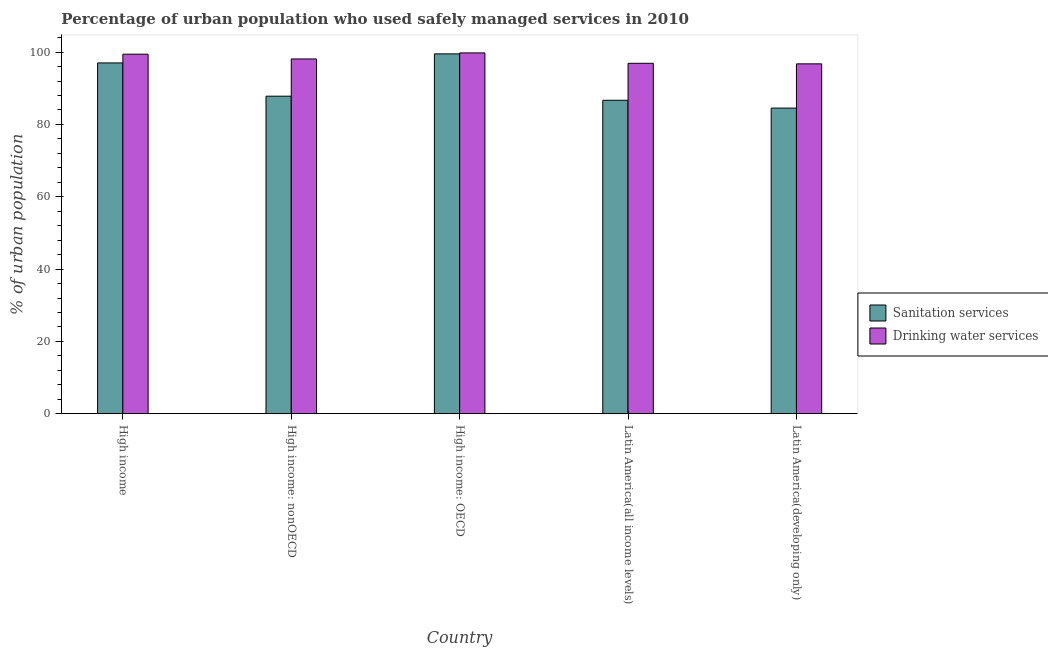How many groups of bars are there?
Give a very brief answer. 5. Are the number of bars on each tick of the X-axis equal?
Your answer should be compact. Yes. How many bars are there on the 5th tick from the left?
Offer a terse response. 2. What is the label of the 1st group of bars from the left?
Provide a short and direct response. High income. In how many cases, is the number of bars for a given country not equal to the number of legend labels?
Your answer should be very brief. 0. What is the percentage of urban population who used drinking water services in Latin America(all income levels)?
Provide a short and direct response. 96.9. Across all countries, what is the maximum percentage of urban population who used sanitation services?
Your response must be concise. 99.5. Across all countries, what is the minimum percentage of urban population who used drinking water services?
Offer a very short reply. 96.74. In which country was the percentage of urban population who used drinking water services maximum?
Keep it short and to the point. High income: OECD. In which country was the percentage of urban population who used drinking water services minimum?
Give a very brief answer. Latin America(developing only). What is the total percentage of urban population who used sanitation services in the graph?
Offer a terse response. 455.48. What is the difference between the percentage of urban population who used sanitation services in Latin America(all income levels) and that in Latin America(developing only)?
Make the answer very short. 2.16. What is the difference between the percentage of urban population who used drinking water services in Latin America(developing only) and the percentage of urban population who used sanitation services in High income: nonOECD?
Give a very brief answer. 8.94. What is the average percentage of urban population who used drinking water services per country?
Your answer should be compact. 98.18. What is the difference between the percentage of urban population who used drinking water services and percentage of urban population who used sanitation services in Latin America(all income levels)?
Ensure brevity in your answer.  10.23. In how many countries, is the percentage of urban population who used drinking water services greater than 44 %?
Ensure brevity in your answer.  5. What is the ratio of the percentage of urban population who used drinking water services in High income: nonOECD to that in Latin America(all income levels)?
Give a very brief answer. 1.01. What is the difference between the highest and the second highest percentage of urban population who used drinking water services?
Offer a terse response. 0.35. What is the difference between the highest and the lowest percentage of urban population who used drinking water services?
Ensure brevity in your answer.  3.03. In how many countries, is the percentage of urban population who used drinking water services greater than the average percentage of urban population who used drinking water services taken over all countries?
Your response must be concise. 2. Is the sum of the percentage of urban population who used drinking water services in High income: nonOECD and Latin America(all income levels) greater than the maximum percentage of urban population who used sanitation services across all countries?
Keep it short and to the point. Yes. What does the 1st bar from the left in High income represents?
Make the answer very short. Sanitation services. What does the 2nd bar from the right in Latin America(developing only) represents?
Make the answer very short. Sanitation services. How many bars are there?
Give a very brief answer. 10. Are all the bars in the graph horizontal?
Offer a terse response. No. How many countries are there in the graph?
Provide a short and direct response. 5. Does the graph contain any zero values?
Keep it short and to the point. No. What is the title of the graph?
Your answer should be very brief. Percentage of urban population who used safely managed services in 2010. Does "Register a business" appear as one of the legend labels in the graph?
Offer a very short reply. No. What is the label or title of the X-axis?
Ensure brevity in your answer.  Country. What is the label or title of the Y-axis?
Offer a terse response. % of urban population. What is the % of urban population in Sanitation services in High income?
Provide a short and direct response. 96.99. What is the % of urban population in Drinking water services in High income?
Give a very brief answer. 99.41. What is the % of urban population of Sanitation services in High income: nonOECD?
Offer a terse response. 87.8. What is the % of urban population of Drinking water services in High income: nonOECD?
Provide a short and direct response. 98.1. What is the % of urban population of Sanitation services in High income: OECD?
Your answer should be very brief. 99.5. What is the % of urban population in Drinking water services in High income: OECD?
Your response must be concise. 99.77. What is the % of urban population in Sanitation services in Latin America(all income levels)?
Your response must be concise. 86.67. What is the % of urban population in Drinking water services in Latin America(all income levels)?
Provide a succinct answer. 96.9. What is the % of urban population of Sanitation services in Latin America(developing only)?
Give a very brief answer. 84.51. What is the % of urban population in Drinking water services in Latin America(developing only)?
Your response must be concise. 96.74. Across all countries, what is the maximum % of urban population in Sanitation services?
Your response must be concise. 99.5. Across all countries, what is the maximum % of urban population of Drinking water services?
Keep it short and to the point. 99.77. Across all countries, what is the minimum % of urban population in Sanitation services?
Keep it short and to the point. 84.51. Across all countries, what is the minimum % of urban population of Drinking water services?
Offer a very short reply. 96.74. What is the total % of urban population of Sanitation services in the graph?
Offer a terse response. 455.48. What is the total % of urban population in Drinking water services in the graph?
Give a very brief answer. 490.91. What is the difference between the % of urban population of Sanitation services in High income and that in High income: nonOECD?
Keep it short and to the point. 9.19. What is the difference between the % of urban population of Drinking water services in High income and that in High income: nonOECD?
Provide a succinct answer. 1.32. What is the difference between the % of urban population in Sanitation services in High income and that in High income: OECD?
Your response must be concise. -2.51. What is the difference between the % of urban population of Drinking water services in High income and that in High income: OECD?
Provide a succinct answer. -0.35. What is the difference between the % of urban population in Sanitation services in High income and that in Latin America(all income levels)?
Provide a short and direct response. 10.32. What is the difference between the % of urban population in Drinking water services in High income and that in Latin America(all income levels)?
Make the answer very short. 2.51. What is the difference between the % of urban population of Sanitation services in High income and that in Latin America(developing only)?
Your response must be concise. 12.48. What is the difference between the % of urban population in Drinking water services in High income and that in Latin America(developing only)?
Your response must be concise. 2.67. What is the difference between the % of urban population in Sanitation services in High income: nonOECD and that in High income: OECD?
Keep it short and to the point. -11.7. What is the difference between the % of urban population of Drinking water services in High income: nonOECD and that in High income: OECD?
Make the answer very short. -1.67. What is the difference between the % of urban population of Sanitation services in High income: nonOECD and that in Latin America(all income levels)?
Offer a very short reply. 1.13. What is the difference between the % of urban population of Drinking water services in High income: nonOECD and that in Latin America(all income levels)?
Your answer should be compact. 1.2. What is the difference between the % of urban population in Sanitation services in High income: nonOECD and that in Latin America(developing only)?
Your response must be concise. 3.29. What is the difference between the % of urban population of Drinking water services in High income: nonOECD and that in Latin America(developing only)?
Your answer should be very brief. 1.36. What is the difference between the % of urban population of Sanitation services in High income: OECD and that in Latin America(all income levels)?
Ensure brevity in your answer.  12.83. What is the difference between the % of urban population of Drinking water services in High income: OECD and that in Latin America(all income levels)?
Ensure brevity in your answer.  2.87. What is the difference between the % of urban population in Sanitation services in High income: OECD and that in Latin America(developing only)?
Provide a succinct answer. 14.99. What is the difference between the % of urban population of Drinking water services in High income: OECD and that in Latin America(developing only)?
Provide a succinct answer. 3.03. What is the difference between the % of urban population of Sanitation services in Latin America(all income levels) and that in Latin America(developing only)?
Give a very brief answer. 2.16. What is the difference between the % of urban population of Drinking water services in Latin America(all income levels) and that in Latin America(developing only)?
Provide a short and direct response. 0.16. What is the difference between the % of urban population in Sanitation services in High income and the % of urban population in Drinking water services in High income: nonOECD?
Offer a very short reply. -1.1. What is the difference between the % of urban population of Sanitation services in High income and the % of urban population of Drinking water services in High income: OECD?
Your answer should be compact. -2.77. What is the difference between the % of urban population in Sanitation services in High income and the % of urban population in Drinking water services in Latin America(all income levels)?
Give a very brief answer. 0.1. What is the difference between the % of urban population in Sanitation services in High income and the % of urban population in Drinking water services in Latin America(developing only)?
Give a very brief answer. 0.25. What is the difference between the % of urban population of Sanitation services in High income: nonOECD and the % of urban population of Drinking water services in High income: OECD?
Offer a very short reply. -11.96. What is the difference between the % of urban population in Sanitation services in High income: nonOECD and the % of urban population in Drinking water services in Latin America(all income levels)?
Offer a very short reply. -9.1. What is the difference between the % of urban population of Sanitation services in High income: nonOECD and the % of urban population of Drinking water services in Latin America(developing only)?
Keep it short and to the point. -8.94. What is the difference between the % of urban population of Sanitation services in High income: OECD and the % of urban population of Drinking water services in Latin America(all income levels)?
Your answer should be very brief. 2.6. What is the difference between the % of urban population in Sanitation services in High income: OECD and the % of urban population in Drinking water services in Latin America(developing only)?
Provide a succinct answer. 2.76. What is the difference between the % of urban population in Sanitation services in Latin America(all income levels) and the % of urban population in Drinking water services in Latin America(developing only)?
Give a very brief answer. -10.07. What is the average % of urban population of Sanitation services per country?
Offer a very short reply. 91.1. What is the average % of urban population in Drinking water services per country?
Your response must be concise. 98.18. What is the difference between the % of urban population in Sanitation services and % of urban population in Drinking water services in High income?
Your answer should be compact. -2.42. What is the difference between the % of urban population of Sanitation services and % of urban population of Drinking water services in High income: nonOECD?
Offer a very short reply. -10.29. What is the difference between the % of urban population in Sanitation services and % of urban population in Drinking water services in High income: OECD?
Provide a short and direct response. -0.26. What is the difference between the % of urban population in Sanitation services and % of urban population in Drinking water services in Latin America(all income levels)?
Make the answer very short. -10.23. What is the difference between the % of urban population of Sanitation services and % of urban population of Drinking water services in Latin America(developing only)?
Make the answer very short. -12.23. What is the ratio of the % of urban population of Sanitation services in High income to that in High income: nonOECD?
Offer a very short reply. 1.1. What is the ratio of the % of urban population in Drinking water services in High income to that in High income: nonOECD?
Ensure brevity in your answer.  1.01. What is the ratio of the % of urban population in Sanitation services in High income to that in High income: OECD?
Offer a very short reply. 0.97. What is the ratio of the % of urban population in Drinking water services in High income to that in High income: OECD?
Provide a short and direct response. 1. What is the ratio of the % of urban population of Sanitation services in High income to that in Latin America(all income levels)?
Provide a succinct answer. 1.12. What is the ratio of the % of urban population in Drinking water services in High income to that in Latin America(all income levels)?
Give a very brief answer. 1.03. What is the ratio of the % of urban population in Sanitation services in High income to that in Latin America(developing only)?
Offer a terse response. 1.15. What is the ratio of the % of urban population in Drinking water services in High income to that in Latin America(developing only)?
Ensure brevity in your answer.  1.03. What is the ratio of the % of urban population of Sanitation services in High income: nonOECD to that in High income: OECD?
Offer a very short reply. 0.88. What is the ratio of the % of urban population in Drinking water services in High income: nonOECD to that in High income: OECD?
Offer a terse response. 0.98. What is the ratio of the % of urban population of Sanitation services in High income: nonOECD to that in Latin America(all income levels)?
Your answer should be very brief. 1.01. What is the ratio of the % of urban population in Drinking water services in High income: nonOECD to that in Latin America(all income levels)?
Ensure brevity in your answer.  1.01. What is the ratio of the % of urban population in Sanitation services in High income: nonOECD to that in Latin America(developing only)?
Provide a short and direct response. 1.04. What is the ratio of the % of urban population in Drinking water services in High income: nonOECD to that in Latin America(developing only)?
Ensure brevity in your answer.  1.01. What is the ratio of the % of urban population in Sanitation services in High income: OECD to that in Latin America(all income levels)?
Your answer should be very brief. 1.15. What is the ratio of the % of urban population in Drinking water services in High income: OECD to that in Latin America(all income levels)?
Offer a very short reply. 1.03. What is the ratio of the % of urban population of Sanitation services in High income: OECD to that in Latin America(developing only)?
Ensure brevity in your answer.  1.18. What is the ratio of the % of urban population of Drinking water services in High income: OECD to that in Latin America(developing only)?
Your answer should be very brief. 1.03. What is the ratio of the % of urban population in Sanitation services in Latin America(all income levels) to that in Latin America(developing only)?
Your answer should be compact. 1.03. What is the ratio of the % of urban population in Drinking water services in Latin America(all income levels) to that in Latin America(developing only)?
Make the answer very short. 1. What is the difference between the highest and the second highest % of urban population in Sanitation services?
Provide a succinct answer. 2.51. What is the difference between the highest and the second highest % of urban population in Drinking water services?
Your answer should be very brief. 0.35. What is the difference between the highest and the lowest % of urban population of Sanitation services?
Give a very brief answer. 14.99. What is the difference between the highest and the lowest % of urban population of Drinking water services?
Your response must be concise. 3.03. 